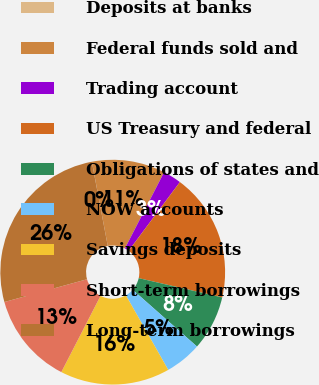<chart> <loc_0><loc_0><loc_500><loc_500><pie_chart><fcel>Deposits at banks<fcel>Federal funds sold and<fcel>Trading account<fcel>US Treasury and federal<fcel>Obligations of states and<fcel>NOW accounts<fcel>Savings deposits<fcel>Short-term borrowings<fcel>Long-term borrowings<nl><fcel>0.01%<fcel>10.53%<fcel>2.64%<fcel>18.42%<fcel>7.9%<fcel>5.27%<fcel>15.79%<fcel>13.16%<fcel>26.31%<nl></chart> 